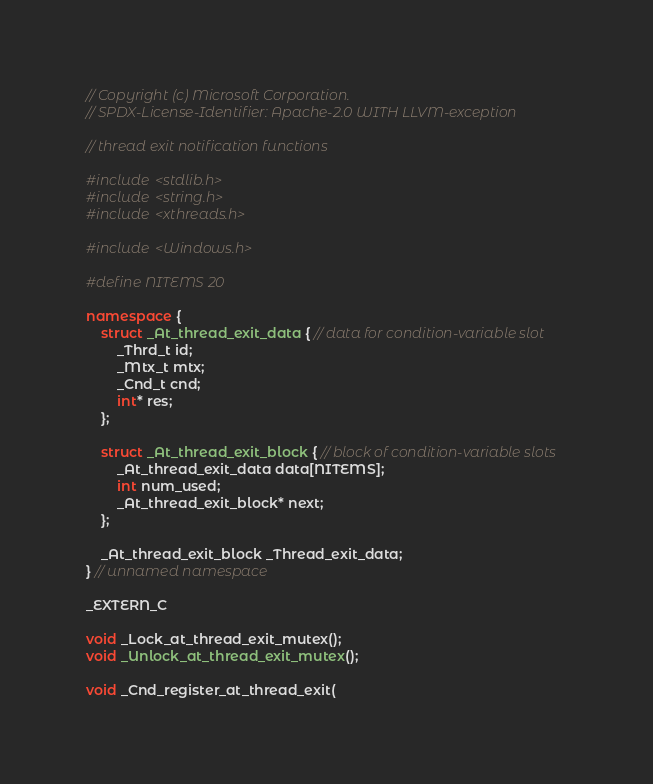Convert code to text. <code><loc_0><loc_0><loc_500><loc_500><_C++_>// Copyright (c) Microsoft Corporation.
// SPDX-License-Identifier: Apache-2.0 WITH LLVM-exception

// thread exit notification functions

#include <stdlib.h>
#include <string.h>
#include <xthreads.h>

#include <Windows.h>

#define NITEMS 20

namespace {
    struct _At_thread_exit_data { // data for condition-variable slot
        _Thrd_t id;
        _Mtx_t mtx;
        _Cnd_t cnd;
        int* res;
    };

    struct _At_thread_exit_block { // block of condition-variable slots
        _At_thread_exit_data data[NITEMS];
        int num_used;
        _At_thread_exit_block* next;
    };

    _At_thread_exit_block _Thread_exit_data;
} // unnamed namespace

_EXTERN_C

void _Lock_at_thread_exit_mutex();
void _Unlock_at_thread_exit_mutex();

void _Cnd_register_at_thread_exit(</code> 